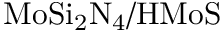<formula> <loc_0><loc_0><loc_500><loc_500>M o S i _ { 2 } N _ { 4 } / H M o S</formula> 